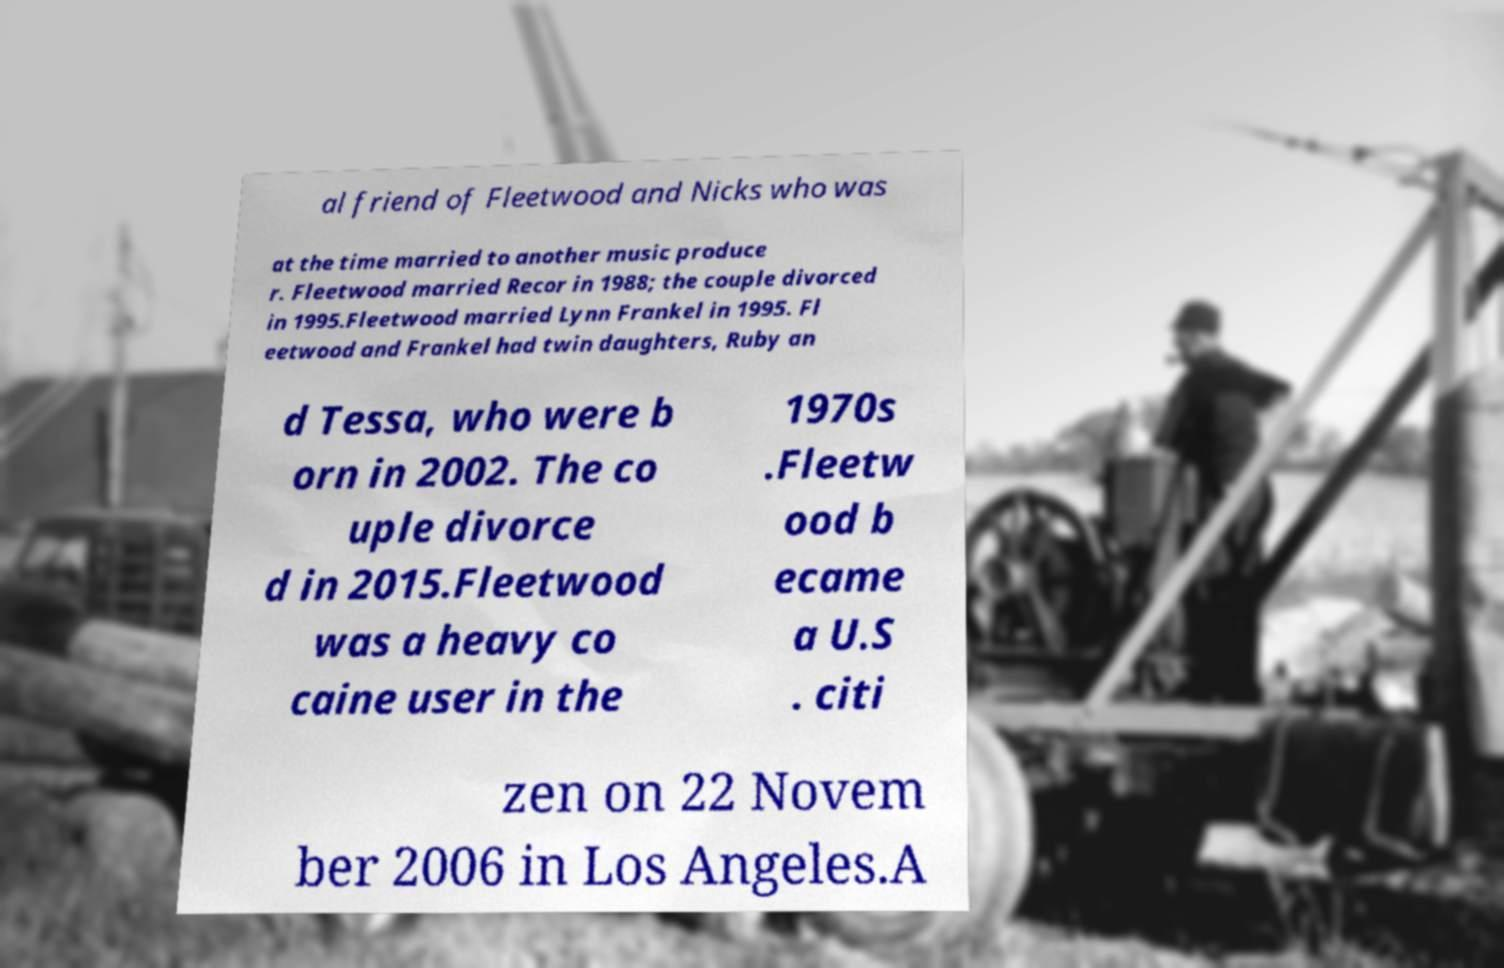Please read and relay the text visible in this image. What does it say? al friend of Fleetwood and Nicks who was at the time married to another music produce r. Fleetwood married Recor in 1988; the couple divorced in 1995.Fleetwood married Lynn Frankel in 1995. Fl eetwood and Frankel had twin daughters, Ruby an d Tessa, who were b orn in 2002. The co uple divorce d in 2015.Fleetwood was a heavy co caine user in the 1970s .Fleetw ood b ecame a U.S . citi zen on 22 Novem ber 2006 in Los Angeles.A 